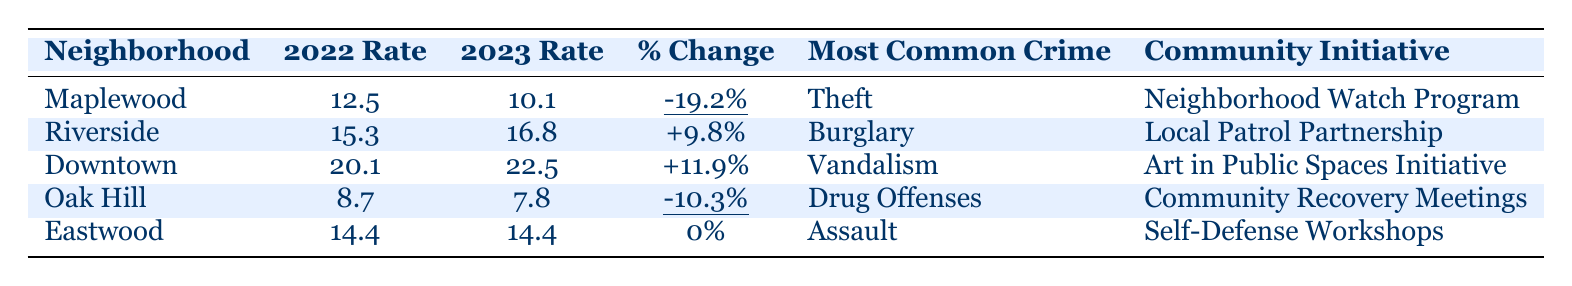What was the crime rate in Maplewood in 2022? The table shows the crime rate for Maplewood in 2022 as 12.5.
Answer: 12.5 What is the most common crime reported in Riverside? According to the table, the most common crime in Riverside is Burglary.
Answer: Burglary Did Downtown experience an increase or decrease in crime rate from 2022 to 2023? By comparing the crime rates, Downtown's rate increased from 20.1 in 2022 to 22.5 in 2023, indicating an increase.
Answer: Increase Which neighborhood had the largest decrease in crime rate from 2022 to 2023? To find this, look for the largest negative percentage change; Maplewood shows a decrease of -19.2%, which is greater than the -10.3% in Oak Hill.
Answer: Maplewood What is the average crime rate for the neighborhoods in 2023? Add the crime rates for all neighborhoods in 2023 (10.1 + 16.8 + 22.5 + 7.8 + 14.4 = 71.6) and divide by the number of neighborhoods (5), giving an average of 14.32.
Answer: 14.32 Was there any neighborhood that reported no change in crime rate between 2022 and 2023? The table indicates that Eastwood showed a 0% change in crime rate from 2022 to 2023.
Answer: Yes Which community engagement initiative is associated with Oak Hill? The initiative listed for Oak Hill in the table is "Community Recovery Meetings."
Answer: Community Recovery Meetings If we combine the changes in crime rates for Maplewood and Oak Hill, what is the total percentage change? Maplewood had a -19.2% change and Oak Hill had a -10.3% change. Summing these gives -29.5%.
Answer: -29.5% What crime was most prevalent in Eastwood in 2022? The table indicates that the most common crime in Eastwood is Assault, consistent for both years.
Answer: Assault Is Riverside's crime rate higher than the average rate for all neighborhoods in 2022? Riverside's crime rate in 2022 is 15.3; the average for all neighborhoods in 2022 is (12.5 + 15.3 + 20.1 + 8.7 + 14.4 = 71.0) / 5 = 14.2, which means Riverside is higher than the average.
Answer: Yes 